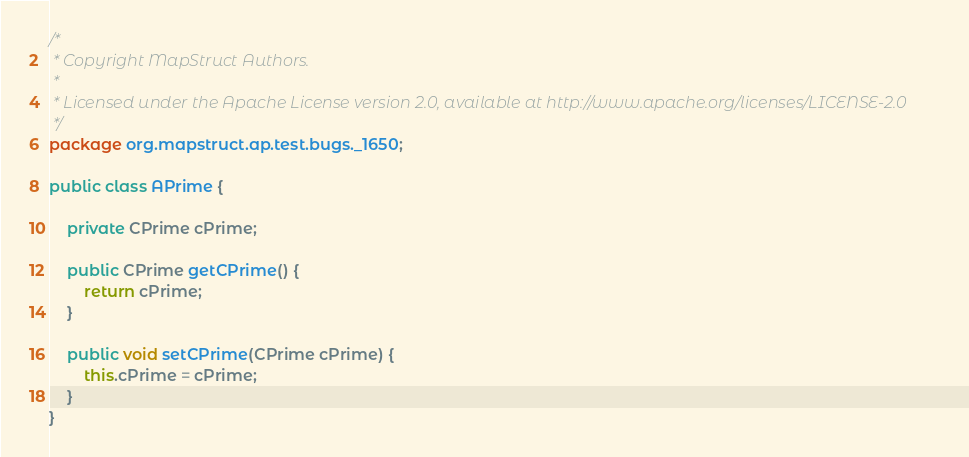<code> <loc_0><loc_0><loc_500><loc_500><_Java_>/*
 * Copyright MapStruct Authors.
 *
 * Licensed under the Apache License version 2.0, available at http://www.apache.org/licenses/LICENSE-2.0
 */
package org.mapstruct.ap.test.bugs._1650;

public class APrime {

    private CPrime cPrime;

    public CPrime getCPrime() {
        return cPrime;
    }

    public void setCPrime(CPrime cPrime) {
        this.cPrime = cPrime;
    }
}
</code> 